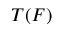Convert formula to latex. <formula><loc_0><loc_0><loc_500><loc_500>T ( F )</formula> 